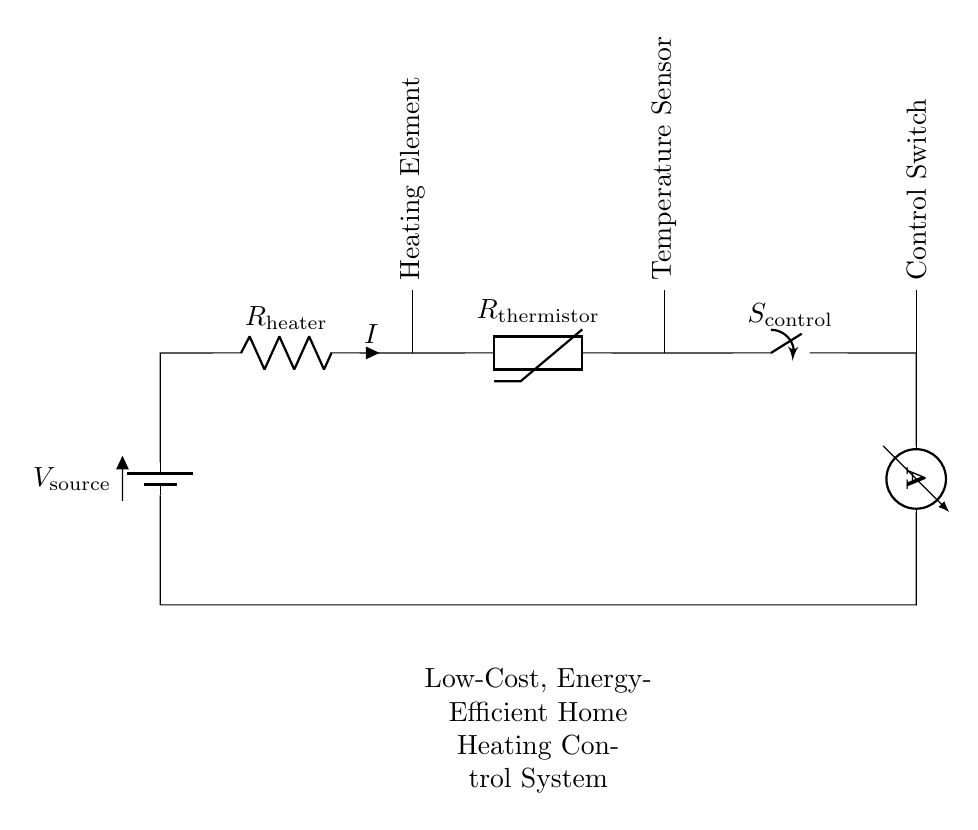What is the type of the circuit? The circuit is a series circuit because all components are connected end-to-end in a single path for current to flow.
Answer: series circuit What does the switch control? The switch controls the flow of current through the heater, allowing it to be turned on or off.
Answer: heater What component measures current? The ammeter measures the current flowing through the circuit, providing a direct reading of current intensity.
Answer: ammeter How many resistive components are present? There are two resistive components: the heater and the thermistor, which both provide resistance in the circuit.
Answer: two What is the function of the thermistor? The thermistor serves as a temperature sensor, adjusting resistance based on temperature changes to control heating.
Answer: temperature sensor If the resistance of the heater is increased, what happens to the current? If the resistance of the heater is increased, the current will decrease according to Ohm's law, since current is inversely proportional to resistance in a series circuit.
Answer: decrease What happens when the switch is open? When the switch is open, there is a break in the circuit, preventing any current from flowing through and turning off the heater.
Answer: no current 